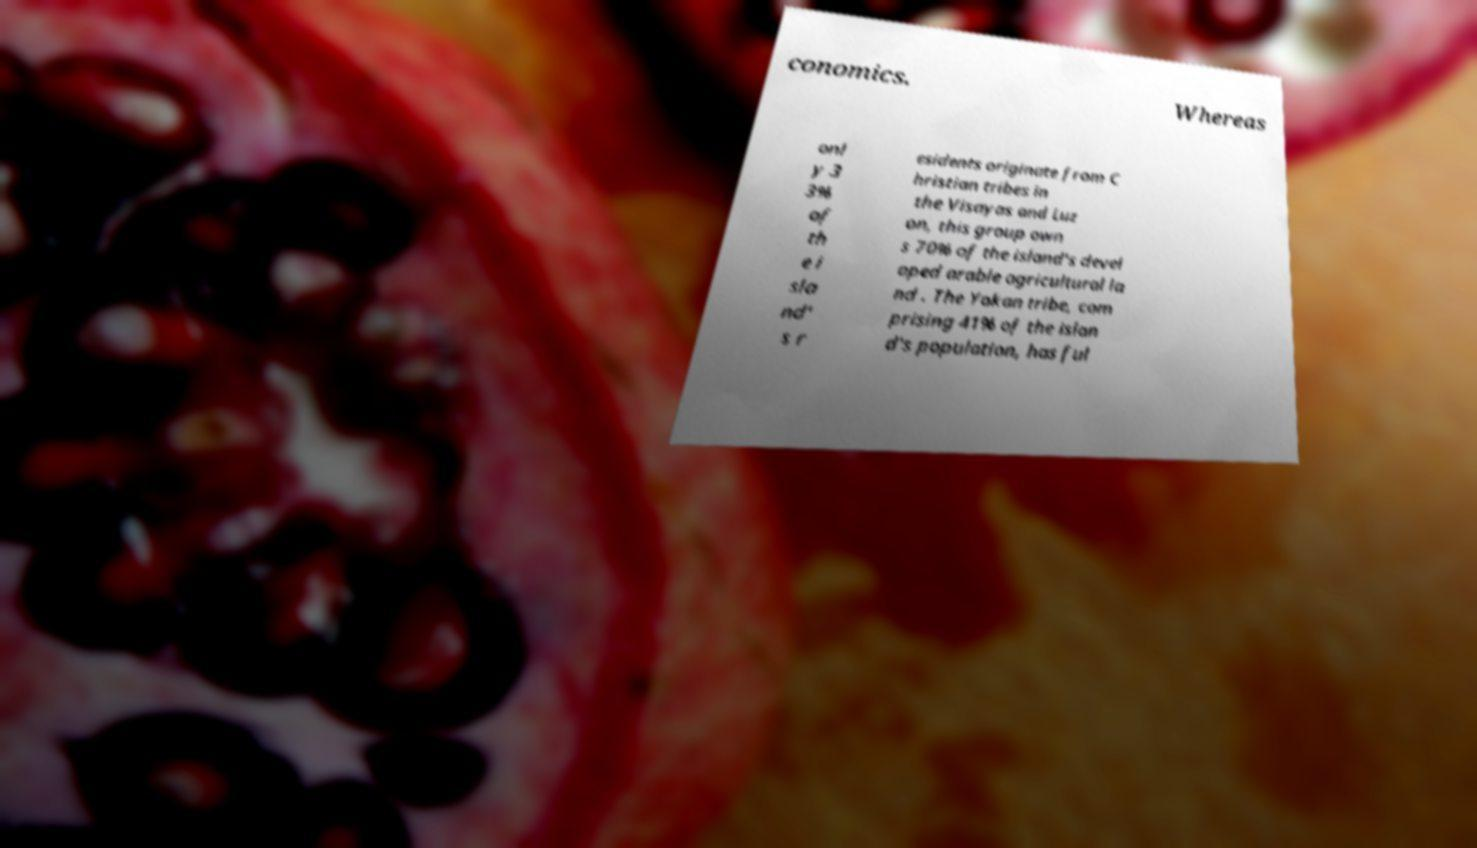Please identify and transcribe the text found in this image. conomics. Whereas onl y 3 3% of th e i sla nd' s r esidents originate from C hristian tribes in the Visayas and Luz on, this group own s 70% of the island's devel oped arable agricultural la nd . The Yakan tribe, com prising 41% of the islan d's population, has ful 